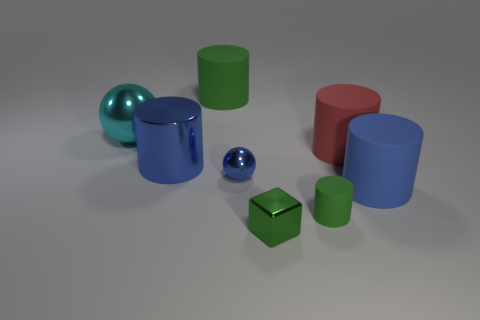Add 1 blue shiny balls. How many objects exist? 9 Subtract all blue metallic cylinders. How many cylinders are left? 4 Subtract 2 cylinders. How many cylinders are left? 3 Subtract all blue cylinders. How many cylinders are left? 3 Subtract all cylinders. How many objects are left? 3 Subtract all brown cubes. How many brown spheres are left? 0 Add 4 big shiny cylinders. How many big shiny cylinders exist? 5 Subtract 1 cyan spheres. How many objects are left? 7 Subtract all yellow balls. Subtract all blue cubes. How many balls are left? 2 Subtract all big cylinders. Subtract all tiny metallic things. How many objects are left? 2 